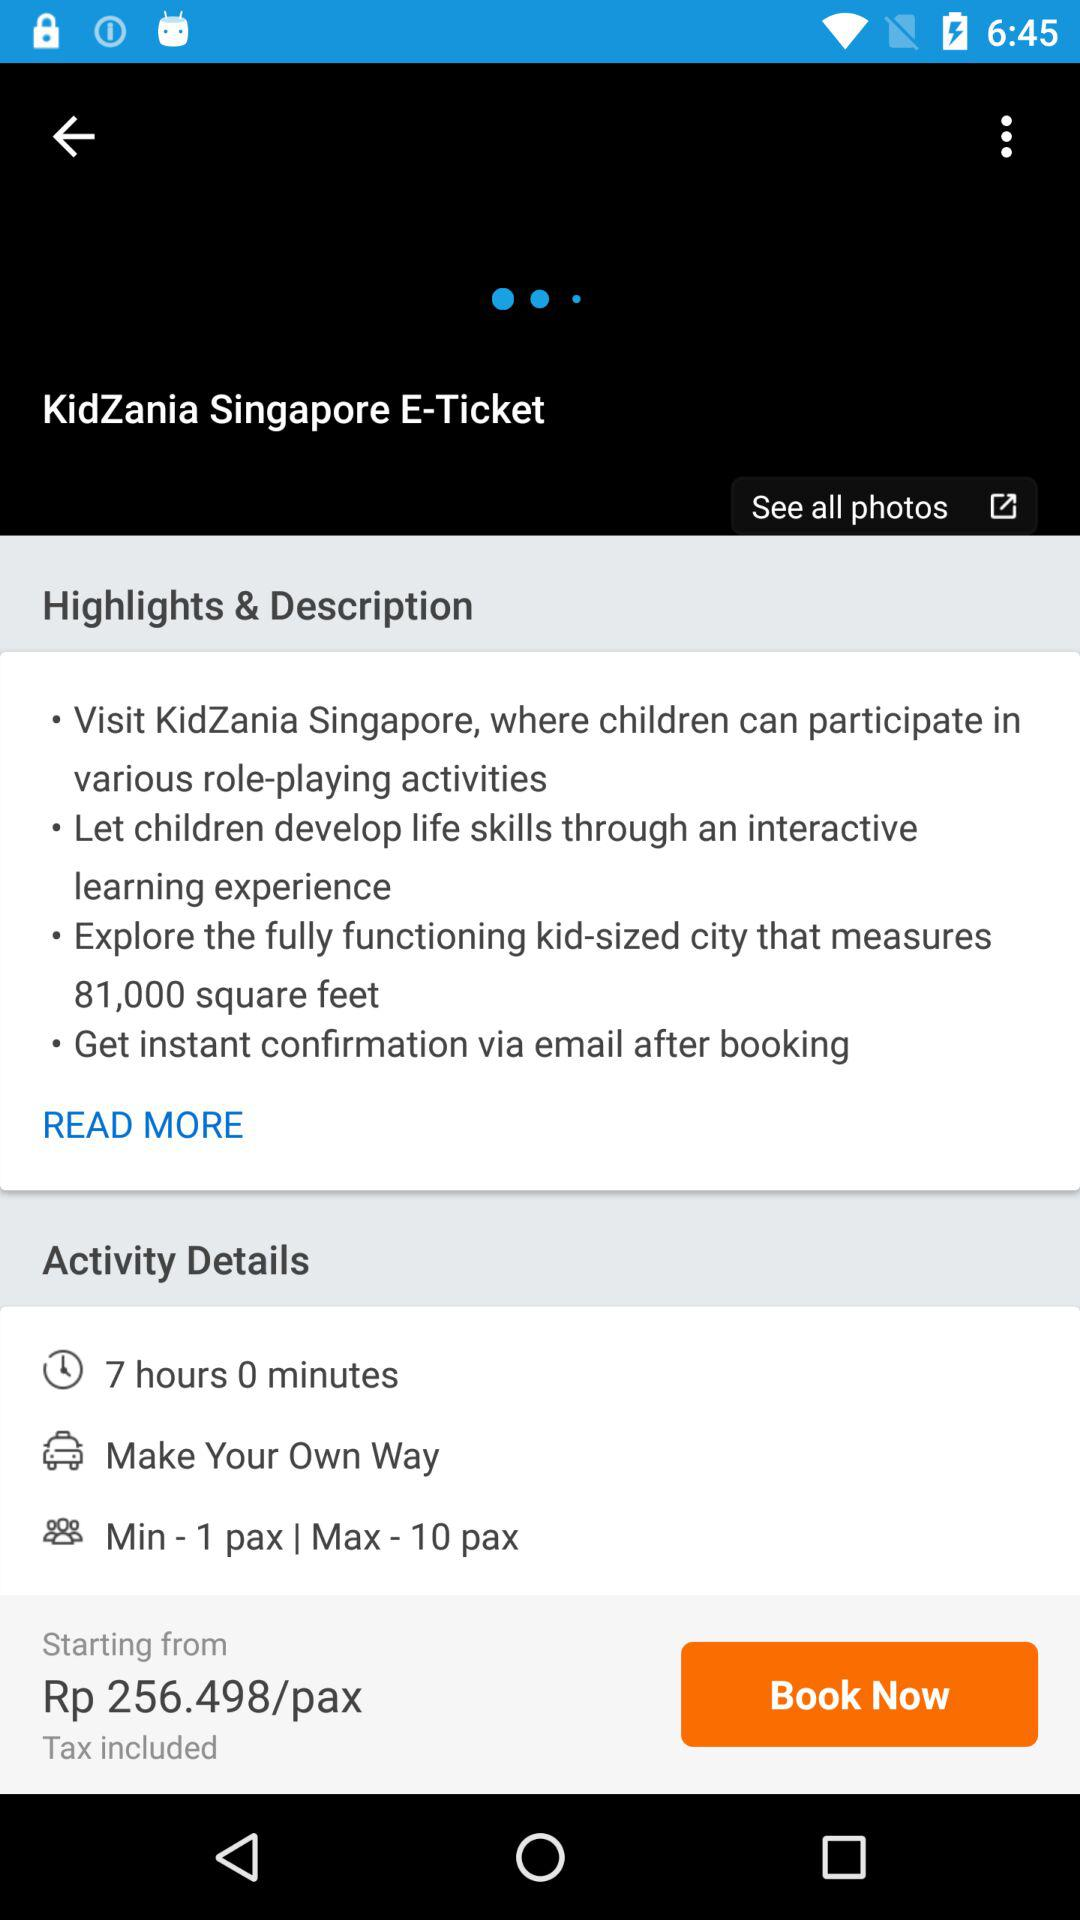What's the number of minimum and maximum pax? The number of minimum and maximum pax are 1 and 10. 